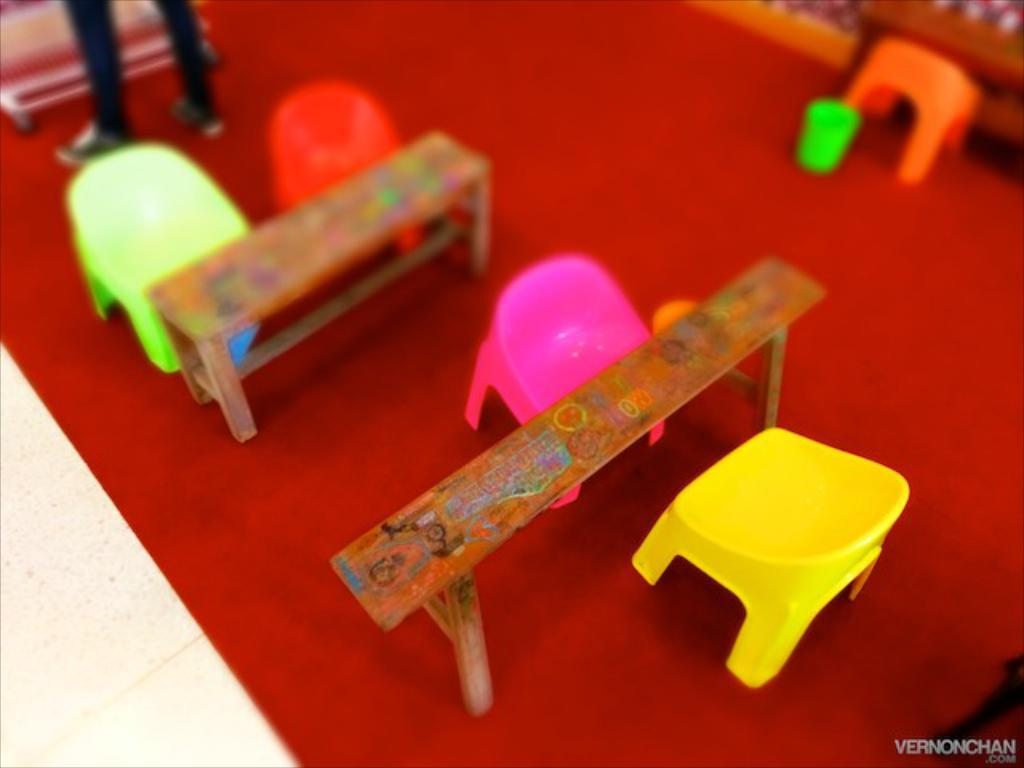What type of furniture is present in the image? There is a table in the image. What is the color of the carpet on which the chairs are placed? The carpet is red. Can you describe the position of the chairs in the image? The chairs are placed on the red color carpet. Is there any person visible in the image? Yes, there is a person standing in the top right corner of the image. What type of guitar is the person playing in the image? There is no guitar present in the image; the person is standing without any musical instrument. 